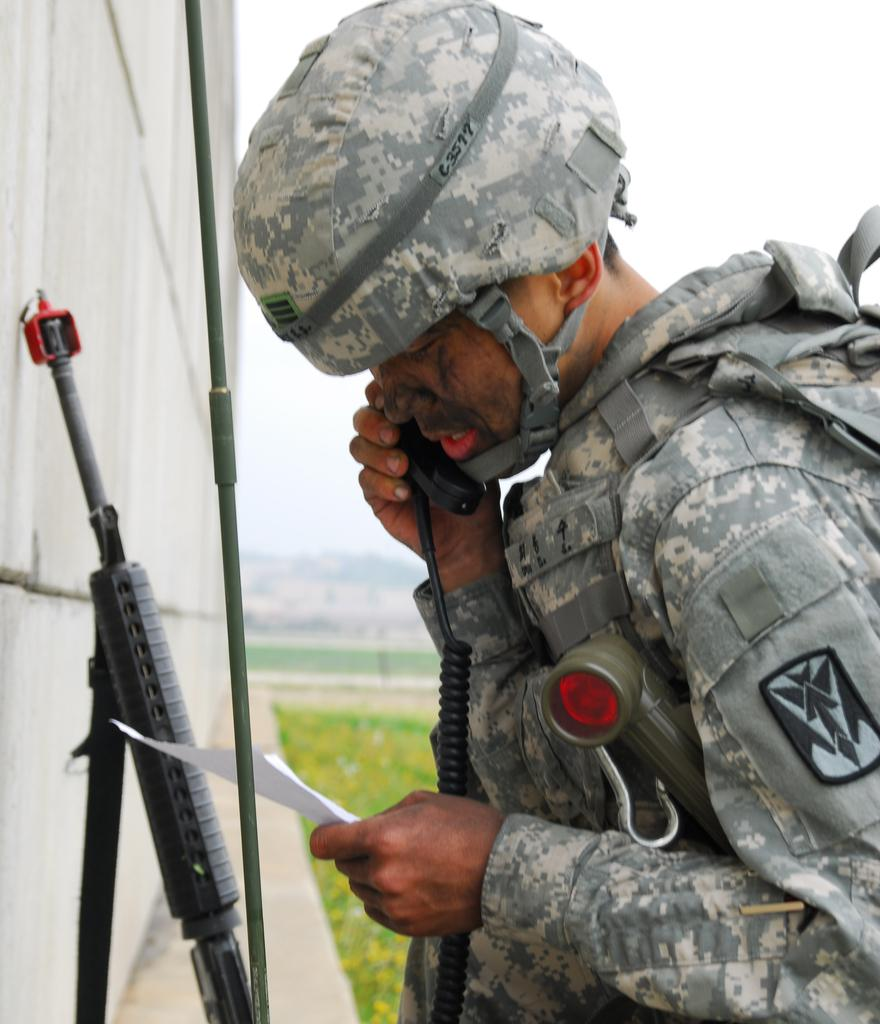What is the man in the image holding? The man in the image is holding weapons. What can be seen behind the man in the image? There is a wall in the image. What type of terrain is visible in the image? There are hills in the image. What is visible above the man and the wall in the image? The sky is visible in the image. What is visible below the man and the wall in the image? The ground is visible in the image. How many kittens are playing with a pipe in the image? There are no kittens or pipes present in the image. Is the man in the image walking on the moon? The image does not depict a space setting, and there is no indication that the man is walking on the moon. 